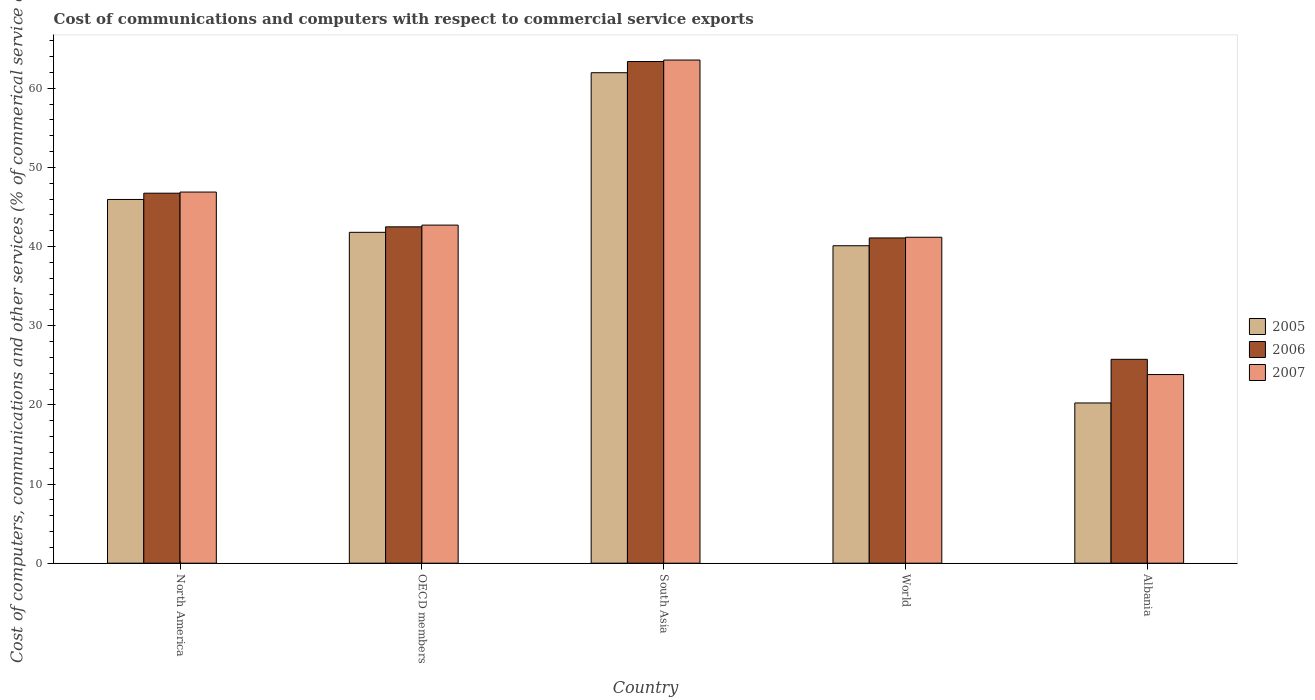How many different coloured bars are there?
Your response must be concise. 3. How many groups of bars are there?
Offer a very short reply. 5. How many bars are there on the 4th tick from the left?
Give a very brief answer. 3. What is the cost of communications and computers in 2005 in North America?
Offer a very short reply. 45.96. Across all countries, what is the maximum cost of communications and computers in 2007?
Provide a succinct answer. 63.57. Across all countries, what is the minimum cost of communications and computers in 2006?
Give a very brief answer. 25.76. In which country was the cost of communications and computers in 2005 minimum?
Ensure brevity in your answer.  Albania. What is the total cost of communications and computers in 2006 in the graph?
Make the answer very short. 219.47. What is the difference between the cost of communications and computers in 2007 in South Asia and that in World?
Offer a very short reply. 22.39. What is the difference between the cost of communications and computers in 2005 in North America and the cost of communications and computers in 2007 in World?
Offer a very short reply. 4.78. What is the average cost of communications and computers in 2005 per country?
Your answer should be very brief. 42.02. What is the difference between the cost of communications and computers of/in 2007 and cost of communications and computers of/in 2005 in Albania?
Make the answer very short. 3.59. In how many countries, is the cost of communications and computers in 2006 greater than 16 %?
Your answer should be compact. 5. What is the ratio of the cost of communications and computers in 2007 in South Asia to that in World?
Ensure brevity in your answer.  1.54. Is the difference between the cost of communications and computers in 2007 in Albania and OECD members greater than the difference between the cost of communications and computers in 2005 in Albania and OECD members?
Keep it short and to the point. Yes. What is the difference between the highest and the second highest cost of communications and computers in 2007?
Provide a short and direct response. -4.17. What is the difference between the highest and the lowest cost of communications and computers in 2006?
Keep it short and to the point. 37.62. In how many countries, is the cost of communications and computers in 2006 greater than the average cost of communications and computers in 2006 taken over all countries?
Give a very brief answer. 2. What does the 3rd bar from the left in North America represents?
Provide a short and direct response. 2007. What does the 3rd bar from the right in Albania represents?
Offer a very short reply. 2005. Is it the case that in every country, the sum of the cost of communications and computers in 2007 and cost of communications and computers in 2005 is greater than the cost of communications and computers in 2006?
Offer a very short reply. Yes. How many bars are there?
Provide a short and direct response. 15. Are all the bars in the graph horizontal?
Your answer should be compact. No. What is the difference between two consecutive major ticks on the Y-axis?
Provide a succinct answer. 10. How many legend labels are there?
Ensure brevity in your answer.  3. What is the title of the graph?
Your answer should be compact. Cost of communications and computers with respect to commercial service exports. Does "2003" appear as one of the legend labels in the graph?
Provide a succinct answer. No. What is the label or title of the Y-axis?
Make the answer very short. Cost of computers, communications and other services (% of commerical service exports). What is the Cost of computers, communications and other services (% of commerical service exports) of 2005 in North America?
Your answer should be very brief. 45.96. What is the Cost of computers, communications and other services (% of commerical service exports) of 2006 in North America?
Your answer should be compact. 46.75. What is the Cost of computers, communications and other services (% of commerical service exports) in 2007 in North America?
Give a very brief answer. 46.89. What is the Cost of computers, communications and other services (% of commerical service exports) of 2005 in OECD members?
Ensure brevity in your answer.  41.8. What is the Cost of computers, communications and other services (% of commerical service exports) of 2006 in OECD members?
Keep it short and to the point. 42.5. What is the Cost of computers, communications and other services (% of commerical service exports) of 2007 in OECD members?
Your answer should be very brief. 42.72. What is the Cost of computers, communications and other services (% of commerical service exports) of 2005 in South Asia?
Your answer should be very brief. 61.97. What is the Cost of computers, communications and other services (% of commerical service exports) in 2006 in South Asia?
Your answer should be compact. 63.38. What is the Cost of computers, communications and other services (% of commerical service exports) of 2007 in South Asia?
Offer a very short reply. 63.57. What is the Cost of computers, communications and other services (% of commerical service exports) of 2005 in World?
Make the answer very short. 40.11. What is the Cost of computers, communications and other services (% of commerical service exports) in 2006 in World?
Provide a short and direct response. 41.09. What is the Cost of computers, communications and other services (% of commerical service exports) of 2007 in World?
Offer a very short reply. 41.18. What is the Cost of computers, communications and other services (% of commerical service exports) of 2005 in Albania?
Provide a short and direct response. 20.24. What is the Cost of computers, communications and other services (% of commerical service exports) of 2006 in Albania?
Provide a short and direct response. 25.76. What is the Cost of computers, communications and other services (% of commerical service exports) in 2007 in Albania?
Keep it short and to the point. 23.83. Across all countries, what is the maximum Cost of computers, communications and other services (% of commerical service exports) of 2005?
Offer a terse response. 61.97. Across all countries, what is the maximum Cost of computers, communications and other services (% of commerical service exports) of 2006?
Keep it short and to the point. 63.38. Across all countries, what is the maximum Cost of computers, communications and other services (% of commerical service exports) in 2007?
Keep it short and to the point. 63.57. Across all countries, what is the minimum Cost of computers, communications and other services (% of commerical service exports) in 2005?
Ensure brevity in your answer.  20.24. Across all countries, what is the minimum Cost of computers, communications and other services (% of commerical service exports) of 2006?
Offer a very short reply. 25.76. Across all countries, what is the minimum Cost of computers, communications and other services (% of commerical service exports) of 2007?
Provide a succinct answer. 23.83. What is the total Cost of computers, communications and other services (% of commerical service exports) in 2005 in the graph?
Provide a short and direct response. 210.08. What is the total Cost of computers, communications and other services (% of commerical service exports) of 2006 in the graph?
Provide a short and direct response. 219.47. What is the total Cost of computers, communications and other services (% of commerical service exports) in 2007 in the graph?
Your answer should be compact. 218.19. What is the difference between the Cost of computers, communications and other services (% of commerical service exports) in 2005 in North America and that in OECD members?
Offer a very short reply. 4.15. What is the difference between the Cost of computers, communications and other services (% of commerical service exports) of 2006 in North America and that in OECD members?
Give a very brief answer. 4.25. What is the difference between the Cost of computers, communications and other services (% of commerical service exports) in 2007 in North America and that in OECD members?
Your answer should be compact. 4.17. What is the difference between the Cost of computers, communications and other services (% of commerical service exports) in 2005 in North America and that in South Asia?
Your answer should be compact. -16.01. What is the difference between the Cost of computers, communications and other services (% of commerical service exports) in 2006 in North America and that in South Asia?
Your response must be concise. -16.63. What is the difference between the Cost of computers, communications and other services (% of commerical service exports) in 2007 in North America and that in South Asia?
Provide a succinct answer. -16.68. What is the difference between the Cost of computers, communications and other services (% of commerical service exports) in 2005 in North America and that in World?
Give a very brief answer. 5.85. What is the difference between the Cost of computers, communications and other services (% of commerical service exports) of 2006 in North America and that in World?
Provide a succinct answer. 5.65. What is the difference between the Cost of computers, communications and other services (% of commerical service exports) of 2007 in North America and that in World?
Keep it short and to the point. 5.71. What is the difference between the Cost of computers, communications and other services (% of commerical service exports) in 2005 in North America and that in Albania?
Ensure brevity in your answer.  25.71. What is the difference between the Cost of computers, communications and other services (% of commerical service exports) of 2006 in North America and that in Albania?
Your answer should be very brief. 20.99. What is the difference between the Cost of computers, communications and other services (% of commerical service exports) of 2007 in North America and that in Albania?
Provide a succinct answer. 23.05. What is the difference between the Cost of computers, communications and other services (% of commerical service exports) in 2005 in OECD members and that in South Asia?
Give a very brief answer. -20.16. What is the difference between the Cost of computers, communications and other services (% of commerical service exports) in 2006 in OECD members and that in South Asia?
Ensure brevity in your answer.  -20.88. What is the difference between the Cost of computers, communications and other services (% of commerical service exports) of 2007 in OECD members and that in South Asia?
Provide a short and direct response. -20.85. What is the difference between the Cost of computers, communications and other services (% of commerical service exports) in 2005 in OECD members and that in World?
Ensure brevity in your answer.  1.7. What is the difference between the Cost of computers, communications and other services (% of commerical service exports) of 2006 in OECD members and that in World?
Provide a succinct answer. 1.4. What is the difference between the Cost of computers, communications and other services (% of commerical service exports) of 2007 in OECD members and that in World?
Offer a terse response. 1.54. What is the difference between the Cost of computers, communications and other services (% of commerical service exports) in 2005 in OECD members and that in Albania?
Give a very brief answer. 21.56. What is the difference between the Cost of computers, communications and other services (% of commerical service exports) of 2006 in OECD members and that in Albania?
Provide a succinct answer. 16.74. What is the difference between the Cost of computers, communications and other services (% of commerical service exports) of 2007 in OECD members and that in Albania?
Your response must be concise. 18.88. What is the difference between the Cost of computers, communications and other services (% of commerical service exports) of 2005 in South Asia and that in World?
Ensure brevity in your answer.  21.86. What is the difference between the Cost of computers, communications and other services (% of commerical service exports) in 2006 in South Asia and that in World?
Give a very brief answer. 22.29. What is the difference between the Cost of computers, communications and other services (% of commerical service exports) in 2007 in South Asia and that in World?
Make the answer very short. 22.39. What is the difference between the Cost of computers, communications and other services (% of commerical service exports) in 2005 in South Asia and that in Albania?
Make the answer very short. 41.72. What is the difference between the Cost of computers, communications and other services (% of commerical service exports) of 2006 in South Asia and that in Albania?
Provide a succinct answer. 37.62. What is the difference between the Cost of computers, communications and other services (% of commerical service exports) of 2007 in South Asia and that in Albania?
Your answer should be compact. 39.74. What is the difference between the Cost of computers, communications and other services (% of commerical service exports) of 2005 in World and that in Albania?
Provide a short and direct response. 19.86. What is the difference between the Cost of computers, communications and other services (% of commerical service exports) in 2006 in World and that in Albania?
Provide a succinct answer. 15.33. What is the difference between the Cost of computers, communications and other services (% of commerical service exports) in 2007 in World and that in Albania?
Offer a terse response. 17.34. What is the difference between the Cost of computers, communications and other services (% of commerical service exports) in 2005 in North America and the Cost of computers, communications and other services (% of commerical service exports) in 2006 in OECD members?
Offer a terse response. 3.46. What is the difference between the Cost of computers, communications and other services (% of commerical service exports) in 2005 in North America and the Cost of computers, communications and other services (% of commerical service exports) in 2007 in OECD members?
Offer a very short reply. 3.24. What is the difference between the Cost of computers, communications and other services (% of commerical service exports) of 2006 in North America and the Cost of computers, communications and other services (% of commerical service exports) of 2007 in OECD members?
Make the answer very short. 4.03. What is the difference between the Cost of computers, communications and other services (% of commerical service exports) in 2005 in North America and the Cost of computers, communications and other services (% of commerical service exports) in 2006 in South Asia?
Ensure brevity in your answer.  -17.43. What is the difference between the Cost of computers, communications and other services (% of commerical service exports) in 2005 in North America and the Cost of computers, communications and other services (% of commerical service exports) in 2007 in South Asia?
Provide a succinct answer. -17.61. What is the difference between the Cost of computers, communications and other services (% of commerical service exports) of 2006 in North America and the Cost of computers, communications and other services (% of commerical service exports) of 2007 in South Asia?
Your answer should be very brief. -16.82. What is the difference between the Cost of computers, communications and other services (% of commerical service exports) in 2005 in North America and the Cost of computers, communications and other services (% of commerical service exports) in 2006 in World?
Provide a succinct answer. 4.86. What is the difference between the Cost of computers, communications and other services (% of commerical service exports) of 2005 in North America and the Cost of computers, communications and other services (% of commerical service exports) of 2007 in World?
Ensure brevity in your answer.  4.78. What is the difference between the Cost of computers, communications and other services (% of commerical service exports) of 2006 in North America and the Cost of computers, communications and other services (% of commerical service exports) of 2007 in World?
Your response must be concise. 5.57. What is the difference between the Cost of computers, communications and other services (% of commerical service exports) in 2005 in North America and the Cost of computers, communications and other services (% of commerical service exports) in 2006 in Albania?
Give a very brief answer. 20.2. What is the difference between the Cost of computers, communications and other services (% of commerical service exports) in 2005 in North America and the Cost of computers, communications and other services (% of commerical service exports) in 2007 in Albania?
Ensure brevity in your answer.  22.12. What is the difference between the Cost of computers, communications and other services (% of commerical service exports) in 2006 in North America and the Cost of computers, communications and other services (% of commerical service exports) in 2007 in Albania?
Your response must be concise. 22.91. What is the difference between the Cost of computers, communications and other services (% of commerical service exports) in 2005 in OECD members and the Cost of computers, communications and other services (% of commerical service exports) in 2006 in South Asia?
Offer a terse response. -21.58. What is the difference between the Cost of computers, communications and other services (% of commerical service exports) of 2005 in OECD members and the Cost of computers, communications and other services (% of commerical service exports) of 2007 in South Asia?
Offer a very short reply. -21.77. What is the difference between the Cost of computers, communications and other services (% of commerical service exports) of 2006 in OECD members and the Cost of computers, communications and other services (% of commerical service exports) of 2007 in South Asia?
Offer a very short reply. -21.07. What is the difference between the Cost of computers, communications and other services (% of commerical service exports) in 2005 in OECD members and the Cost of computers, communications and other services (% of commerical service exports) in 2006 in World?
Offer a very short reply. 0.71. What is the difference between the Cost of computers, communications and other services (% of commerical service exports) in 2005 in OECD members and the Cost of computers, communications and other services (% of commerical service exports) in 2007 in World?
Provide a succinct answer. 0.62. What is the difference between the Cost of computers, communications and other services (% of commerical service exports) in 2006 in OECD members and the Cost of computers, communications and other services (% of commerical service exports) in 2007 in World?
Your answer should be very brief. 1.32. What is the difference between the Cost of computers, communications and other services (% of commerical service exports) of 2005 in OECD members and the Cost of computers, communications and other services (% of commerical service exports) of 2006 in Albania?
Your response must be concise. 16.05. What is the difference between the Cost of computers, communications and other services (% of commerical service exports) of 2005 in OECD members and the Cost of computers, communications and other services (% of commerical service exports) of 2007 in Albania?
Keep it short and to the point. 17.97. What is the difference between the Cost of computers, communications and other services (% of commerical service exports) of 2006 in OECD members and the Cost of computers, communications and other services (% of commerical service exports) of 2007 in Albania?
Offer a terse response. 18.66. What is the difference between the Cost of computers, communications and other services (% of commerical service exports) in 2005 in South Asia and the Cost of computers, communications and other services (% of commerical service exports) in 2006 in World?
Offer a terse response. 20.88. What is the difference between the Cost of computers, communications and other services (% of commerical service exports) of 2005 in South Asia and the Cost of computers, communications and other services (% of commerical service exports) of 2007 in World?
Offer a very short reply. 20.79. What is the difference between the Cost of computers, communications and other services (% of commerical service exports) of 2006 in South Asia and the Cost of computers, communications and other services (% of commerical service exports) of 2007 in World?
Your answer should be very brief. 22.2. What is the difference between the Cost of computers, communications and other services (% of commerical service exports) in 2005 in South Asia and the Cost of computers, communications and other services (% of commerical service exports) in 2006 in Albania?
Your response must be concise. 36.21. What is the difference between the Cost of computers, communications and other services (% of commerical service exports) in 2005 in South Asia and the Cost of computers, communications and other services (% of commerical service exports) in 2007 in Albania?
Provide a short and direct response. 38.13. What is the difference between the Cost of computers, communications and other services (% of commerical service exports) of 2006 in South Asia and the Cost of computers, communications and other services (% of commerical service exports) of 2007 in Albania?
Keep it short and to the point. 39.55. What is the difference between the Cost of computers, communications and other services (% of commerical service exports) in 2005 in World and the Cost of computers, communications and other services (% of commerical service exports) in 2006 in Albania?
Make the answer very short. 14.35. What is the difference between the Cost of computers, communications and other services (% of commerical service exports) in 2005 in World and the Cost of computers, communications and other services (% of commerical service exports) in 2007 in Albania?
Keep it short and to the point. 16.27. What is the difference between the Cost of computers, communications and other services (% of commerical service exports) in 2006 in World and the Cost of computers, communications and other services (% of commerical service exports) in 2007 in Albania?
Your answer should be very brief. 17.26. What is the average Cost of computers, communications and other services (% of commerical service exports) of 2005 per country?
Your answer should be compact. 42.02. What is the average Cost of computers, communications and other services (% of commerical service exports) of 2006 per country?
Offer a terse response. 43.89. What is the average Cost of computers, communications and other services (% of commerical service exports) in 2007 per country?
Your answer should be very brief. 43.64. What is the difference between the Cost of computers, communications and other services (% of commerical service exports) in 2005 and Cost of computers, communications and other services (% of commerical service exports) in 2006 in North America?
Your answer should be very brief. -0.79. What is the difference between the Cost of computers, communications and other services (% of commerical service exports) in 2005 and Cost of computers, communications and other services (% of commerical service exports) in 2007 in North America?
Your response must be concise. -0.93. What is the difference between the Cost of computers, communications and other services (% of commerical service exports) of 2006 and Cost of computers, communications and other services (% of commerical service exports) of 2007 in North America?
Provide a succinct answer. -0.14. What is the difference between the Cost of computers, communications and other services (% of commerical service exports) in 2005 and Cost of computers, communications and other services (% of commerical service exports) in 2006 in OECD members?
Your answer should be compact. -0.69. What is the difference between the Cost of computers, communications and other services (% of commerical service exports) in 2005 and Cost of computers, communications and other services (% of commerical service exports) in 2007 in OECD members?
Your answer should be very brief. -0.91. What is the difference between the Cost of computers, communications and other services (% of commerical service exports) in 2006 and Cost of computers, communications and other services (% of commerical service exports) in 2007 in OECD members?
Your response must be concise. -0.22. What is the difference between the Cost of computers, communications and other services (% of commerical service exports) of 2005 and Cost of computers, communications and other services (% of commerical service exports) of 2006 in South Asia?
Offer a terse response. -1.41. What is the difference between the Cost of computers, communications and other services (% of commerical service exports) of 2005 and Cost of computers, communications and other services (% of commerical service exports) of 2007 in South Asia?
Make the answer very short. -1.6. What is the difference between the Cost of computers, communications and other services (% of commerical service exports) of 2006 and Cost of computers, communications and other services (% of commerical service exports) of 2007 in South Asia?
Ensure brevity in your answer.  -0.19. What is the difference between the Cost of computers, communications and other services (% of commerical service exports) of 2005 and Cost of computers, communications and other services (% of commerical service exports) of 2006 in World?
Provide a short and direct response. -0.98. What is the difference between the Cost of computers, communications and other services (% of commerical service exports) of 2005 and Cost of computers, communications and other services (% of commerical service exports) of 2007 in World?
Your response must be concise. -1.07. What is the difference between the Cost of computers, communications and other services (% of commerical service exports) in 2006 and Cost of computers, communications and other services (% of commerical service exports) in 2007 in World?
Your answer should be very brief. -0.09. What is the difference between the Cost of computers, communications and other services (% of commerical service exports) in 2005 and Cost of computers, communications and other services (% of commerical service exports) in 2006 in Albania?
Make the answer very short. -5.51. What is the difference between the Cost of computers, communications and other services (% of commerical service exports) in 2005 and Cost of computers, communications and other services (% of commerical service exports) in 2007 in Albania?
Your response must be concise. -3.59. What is the difference between the Cost of computers, communications and other services (% of commerical service exports) of 2006 and Cost of computers, communications and other services (% of commerical service exports) of 2007 in Albania?
Give a very brief answer. 1.92. What is the ratio of the Cost of computers, communications and other services (% of commerical service exports) in 2005 in North America to that in OECD members?
Provide a succinct answer. 1.1. What is the ratio of the Cost of computers, communications and other services (% of commerical service exports) of 2006 in North America to that in OECD members?
Ensure brevity in your answer.  1.1. What is the ratio of the Cost of computers, communications and other services (% of commerical service exports) in 2007 in North America to that in OECD members?
Give a very brief answer. 1.1. What is the ratio of the Cost of computers, communications and other services (% of commerical service exports) of 2005 in North America to that in South Asia?
Provide a short and direct response. 0.74. What is the ratio of the Cost of computers, communications and other services (% of commerical service exports) of 2006 in North America to that in South Asia?
Provide a succinct answer. 0.74. What is the ratio of the Cost of computers, communications and other services (% of commerical service exports) of 2007 in North America to that in South Asia?
Ensure brevity in your answer.  0.74. What is the ratio of the Cost of computers, communications and other services (% of commerical service exports) in 2005 in North America to that in World?
Your answer should be very brief. 1.15. What is the ratio of the Cost of computers, communications and other services (% of commerical service exports) of 2006 in North America to that in World?
Make the answer very short. 1.14. What is the ratio of the Cost of computers, communications and other services (% of commerical service exports) in 2007 in North America to that in World?
Offer a very short reply. 1.14. What is the ratio of the Cost of computers, communications and other services (% of commerical service exports) in 2005 in North America to that in Albania?
Make the answer very short. 2.27. What is the ratio of the Cost of computers, communications and other services (% of commerical service exports) in 2006 in North America to that in Albania?
Your response must be concise. 1.81. What is the ratio of the Cost of computers, communications and other services (% of commerical service exports) of 2007 in North America to that in Albania?
Offer a very short reply. 1.97. What is the ratio of the Cost of computers, communications and other services (% of commerical service exports) of 2005 in OECD members to that in South Asia?
Give a very brief answer. 0.67. What is the ratio of the Cost of computers, communications and other services (% of commerical service exports) of 2006 in OECD members to that in South Asia?
Provide a short and direct response. 0.67. What is the ratio of the Cost of computers, communications and other services (% of commerical service exports) of 2007 in OECD members to that in South Asia?
Offer a terse response. 0.67. What is the ratio of the Cost of computers, communications and other services (% of commerical service exports) of 2005 in OECD members to that in World?
Your answer should be compact. 1.04. What is the ratio of the Cost of computers, communications and other services (% of commerical service exports) of 2006 in OECD members to that in World?
Your answer should be compact. 1.03. What is the ratio of the Cost of computers, communications and other services (% of commerical service exports) of 2007 in OECD members to that in World?
Ensure brevity in your answer.  1.04. What is the ratio of the Cost of computers, communications and other services (% of commerical service exports) in 2005 in OECD members to that in Albania?
Your answer should be very brief. 2.06. What is the ratio of the Cost of computers, communications and other services (% of commerical service exports) in 2006 in OECD members to that in Albania?
Your answer should be very brief. 1.65. What is the ratio of the Cost of computers, communications and other services (% of commerical service exports) in 2007 in OECD members to that in Albania?
Your answer should be compact. 1.79. What is the ratio of the Cost of computers, communications and other services (% of commerical service exports) in 2005 in South Asia to that in World?
Offer a very short reply. 1.54. What is the ratio of the Cost of computers, communications and other services (% of commerical service exports) in 2006 in South Asia to that in World?
Offer a very short reply. 1.54. What is the ratio of the Cost of computers, communications and other services (% of commerical service exports) in 2007 in South Asia to that in World?
Provide a succinct answer. 1.54. What is the ratio of the Cost of computers, communications and other services (% of commerical service exports) in 2005 in South Asia to that in Albania?
Offer a very short reply. 3.06. What is the ratio of the Cost of computers, communications and other services (% of commerical service exports) in 2006 in South Asia to that in Albania?
Your answer should be compact. 2.46. What is the ratio of the Cost of computers, communications and other services (% of commerical service exports) in 2007 in South Asia to that in Albania?
Your response must be concise. 2.67. What is the ratio of the Cost of computers, communications and other services (% of commerical service exports) of 2005 in World to that in Albania?
Ensure brevity in your answer.  1.98. What is the ratio of the Cost of computers, communications and other services (% of commerical service exports) in 2006 in World to that in Albania?
Provide a succinct answer. 1.6. What is the ratio of the Cost of computers, communications and other services (% of commerical service exports) of 2007 in World to that in Albania?
Make the answer very short. 1.73. What is the difference between the highest and the second highest Cost of computers, communications and other services (% of commerical service exports) of 2005?
Provide a short and direct response. 16.01. What is the difference between the highest and the second highest Cost of computers, communications and other services (% of commerical service exports) in 2006?
Provide a short and direct response. 16.63. What is the difference between the highest and the second highest Cost of computers, communications and other services (% of commerical service exports) in 2007?
Provide a short and direct response. 16.68. What is the difference between the highest and the lowest Cost of computers, communications and other services (% of commerical service exports) of 2005?
Offer a terse response. 41.72. What is the difference between the highest and the lowest Cost of computers, communications and other services (% of commerical service exports) in 2006?
Offer a terse response. 37.62. What is the difference between the highest and the lowest Cost of computers, communications and other services (% of commerical service exports) of 2007?
Provide a short and direct response. 39.74. 